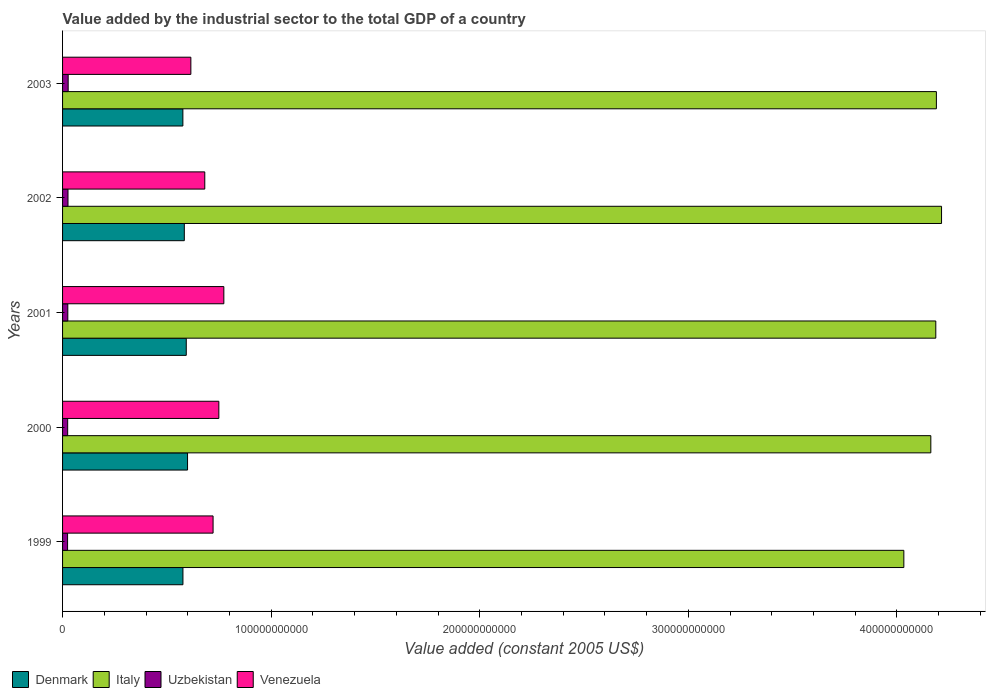How many groups of bars are there?
Your answer should be very brief. 5. In how many cases, is the number of bars for a given year not equal to the number of legend labels?
Provide a succinct answer. 0. What is the value added by the industrial sector in Denmark in 2003?
Keep it short and to the point. 5.77e+1. Across all years, what is the maximum value added by the industrial sector in Venezuela?
Ensure brevity in your answer.  7.73e+1. Across all years, what is the minimum value added by the industrial sector in Italy?
Offer a terse response. 4.03e+11. In which year was the value added by the industrial sector in Denmark maximum?
Ensure brevity in your answer.  2000. What is the total value added by the industrial sector in Venezuela in the graph?
Ensure brevity in your answer.  3.54e+11. What is the difference between the value added by the industrial sector in Italy in 2000 and that in 2003?
Make the answer very short. -2.67e+09. What is the difference between the value added by the industrial sector in Denmark in 1999 and the value added by the industrial sector in Venezuela in 2003?
Provide a short and direct response. -3.80e+09. What is the average value added by the industrial sector in Venezuela per year?
Provide a succinct answer. 7.08e+1. In the year 2003, what is the difference between the value added by the industrial sector in Venezuela and value added by the industrial sector in Italy?
Make the answer very short. -3.57e+11. What is the ratio of the value added by the industrial sector in Denmark in 1999 to that in 2003?
Ensure brevity in your answer.  1. Is the value added by the industrial sector in Italy in 1999 less than that in 2001?
Your response must be concise. Yes. Is the difference between the value added by the industrial sector in Venezuela in 2002 and 2003 greater than the difference between the value added by the industrial sector in Italy in 2002 and 2003?
Offer a very short reply. Yes. What is the difference between the highest and the second highest value added by the industrial sector in Venezuela?
Offer a terse response. 2.40e+09. What is the difference between the highest and the lowest value added by the industrial sector in Venezuela?
Provide a succinct answer. 1.58e+1. Is the sum of the value added by the industrial sector in Uzbekistan in 1999 and 2002 greater than the maximum value added by the industrial sector in Venezuela across all years?
Give a very brief answer. No. Is it the case that in every year, the sum of the value added by the industrial sector in Italy and value added by the industrial sector in Uzbekistan is greater than the value added by the industrial sector in Venezuela?
Provide a succinct answer. Yes. What is the difference between two consecutive major ticks on the X-axis?
Your answer should be compact. 1.00e+11. Does the graph contain grids?
Offer a terse response. No. Where does the legend appear in the graph?
Keep it short and to the point. Bottom left. What is the title of the graph?
Offer a terse response. Value added by the industrial sector to the total GDP of a country. What is the label or title of the X-axis?
Offer a terse response. Value added (constant 2005 US$). What is the label or title of the Y-axis?
Offer a very short reply. Years. What is the Value added (constant 2005 US$) in Denmark in 1999?
Keep it short and to the point. 5.77e+1. What is the Value added (constant 2005 US$) in Italy in 1999?
Offer a terse response. 4.03e+11. What is the Value added (constant 2005 US$) of Uzbekistan in 1999?
Offer a terse response. 2.40e+09. What is the Value added (constant 2005 US$) in Venezuela in 1999?
Offer a terse response. 7.22e+1. What is the Value added (constant 2005 US$) of Denmark in 2000?
Offer a very short reply. 5.99e+1. What is the Value added (constant 2005 US$) in Italy in 2000?
Give a very brief answer. 4.16e+11. What is the Value added (constant 2005 US$) of Uzbekistan in 2000?
Your answer should be compact. 2.45e+09. What is the Value added (constant 2005 US$) of Venezuela in 2000?
Provide a succinct answer. 7.49e+1. What is the Value added (constant 2005 US$) of Denmark in 2001?
Make the answer very short. 5.93e+1. What is the Value added (constant 2005 US$) of Italy in 2001?
Ensure brevity in your answer.  4.19e+11. What is the Value added (constant 2005 US$) in Uzbekistan in 2001?
Your answer should be very brief. 2.52e+09. What is the Value added (constant 2005 US$) of Venezuela in 2001?
Offer a terse response. 7.73e+1. What is the Value added (constant 2005 US$) in Denmark in 2002?
Offer a very short reply. 5.84e+1. What is the Value added (constant 2005 US$) of Italy in 2002?
Offer a very short reply. 4.21e+11. What is the Value added (constant 2005 US$) of Uzbekistan in 2002?
Provide a short and direct response. 2.60e+09. What is the Value added (constant 2005 US$) in Venezuela in 2002?
Your answer should be very brief. 6.82e+1. What is the Value added (constant 2005 US$) in Denmark in 2003?
Provide a short and direct response. 5.77e+1. What is the Value added (constant 2005 US$) in Italy in 2003?
Ensure brevity in your answer.  4.19e+11. What is the Value added (constant 2005 US$) of Uzbekistan in 2003?
Offer a very short reply. 2.69e+09. What is the Value added (constant 2005 US$) in Venezuela in 2003?
Your answer should be compact. 6.15e+1. Across all years, what is the maximum Value added (constant 2005 US$) of Denmark?
Provide a short and direct response. 5.99e+1. Across all years, what is the maximum Value added (constant 2005 US$) in Italy?
Your response must be concise. 4.21e+11. Across all years, what is the maximum Value added (constant 2005 US$) of Uzbekistan?
Make the answer very short. 2.69e+09. Across all years, what is the maximum Value added (constant 2005 US$) in Venezuela?
Give a very brief answer. 7.73e+1. Across all years, what is the minimum Value added (constant 2005 US$) of Denmark?
Ensure brevity in your answer.  5.77e+1. Across all years, what is the minimum Value added (constant 2005 US$) in Italy?
Make the answer very short. 4.03e+11. Across all years, what is the minimum Value added (constant 2005 US$) of Uzbekistan?
Ensure brevity in your answer.  2.40e+09. Across all years, what is the minimum Value added (constant 2005 US$) in Venezuela?
Keep it short and to the point. 6.15e+1. What is the total Value added (constant 2005 US$) of Denmark in the graph?
Provide a short and direct response. 2.93e+11. What is the total Value added (constant 2005 US$) in Italy in the graph?
Keep it short and to the point. 2.08e+12. What is the total Value added (constant 2005 US$) of Uzbekistan in the graph?
Ensure brevity in your answer.  1.27e+1. What is the total Value added (constant 2005 US$) in Venezuela in the graph?
Offer a very short reply. 3.54e+11. What is the difference between the Value added (constant 2005 US$) in Denmark in 1999 and that in 2000?
Offer a terse response. -2.21e+09. What is the difference between the Value added (constant 2005 US$) of Italy in 1999 and that in 2000?
Provide a succinct answer. -1.29e+1. What is the difference between the Value added (constant 2005 US$) in Uzbekistan in 1999 and that in 2000?
Provide a short and direct response. -4.36e+07. What is the difference between the Value added (constant 2005 US$) of Venezuela in 1999 and that in 2000?
Provide a succinct answer. -2.77e+09. What is the difference between the Value added (constant 2005 US$) of Denmark in 1999 and that in 2001?
Give a very brief answer. -1.60e+09. What is the difference between the Value added (constant 2005 US$) of Italy in 1999 and that in 2001?
Keep it short and to the point. -1.53e+1. What is the difference between the Value added (constant 2005 US$) of Uzbekistan in 1999 and that in 2001?
Provide a short and direct response. -1.15e+08. What is the difference between the Value added (constant 2005 US$) of Venezuela in 1999 and that in 2001?
Give a very brief answer. -5.16e+09. What is the difference between the Value added (constant 2005 US$) of Denmark in 1999 and that in 2002?
Ensure brevity in your answer.  -6.62e+08. What is the difference between the Value added (constant 2005 US$) in Italy in 1999 and that in 2002?
Offer a terse response. -1.81e+1. What is the difference between the Value added (constant 2005 US$) of Uzbekistan in 1999 and that in 2002?
Provide a short and direct response. -2.00e+08. What is the difference between the Value added (constant 2005 US$) of Venezuela in 1999 and that in 2002?
Make the answer very short. 3.98e+09. What is the difference between the Value added (constant 2005 US$) in Denmark in 1999 and that in 2003?
Keep it short and to the point. 2.82e+07. What is the difference between the Value added (constant 2005 US$) in Italy in 1999 and that in 2003?
Offer a very short reply. -1.56e+1. What is the difference between the Value added (constant 2005 US$) in Uzbekistan in 1999 and that in 2003?
Make the answer very short. -2.83e+08. What is the difference between the Value added (constant 2005 US$) of Venezuela in 1999 and that in 2003?
Keep it short and to the point. 1.07e+1. What is the difference between the Value added (constant 2005 US$) of Denmark in 2000 and that in 2001?
Keep it short and to the point. 6.13e+08. What is the difference between the Value added (constant 2005 US$) in Italy in 2000 and that in 2001?
Offer a terse response. -2.38e+09. What is the difference between the Value added (constant 2005 US$) in Uzbekistan in 2000 and that in 2001?
Provide a short and direct response. -7.12e+07. What is the difference between the Value added (constant 2005 US$) in Venezuela in 2000 and that in 2001?
Provide a short and direct response. -2.40e+09. What is the difference between the Value added (constant 2005 US$) of Denmark in 2000 and that in 2002?
Give a very brief answer. 1.55e+09. What is the difference between the Value added (constant 2005 US$) in Italy in 2000 and that in 2002?
Offer a terse response. -5.13e+09. What is the difference between the Value added (constant 2005 US$) in Uzbekistan in 2000 and that in 2002?
Ensure brevity in your answer.  -1.57e+08. What is the difference between the Value added (constant 2005 US$) of Venezuela in 2000 and that in 2002?
Give a very brief answer. 6.74e+09. What is the difference between the Value added (constant 2005 US$) of Denmark in 2000 and that in 2003?
Provide a short and direct response. 2.24e+09. What is the difference between the Value added (constant 2005 US$) in Italy in 2000 and that in 2003?
Provide a short and direct response. -2.67e+09. What is the difference between the Value added (constant 2005 US$) of Uzbekistan in 2000 and that in 2003?
Provide a short and direct response. -2.40e+08. What is the difference between the Value added (constant 2005 US$) in Venezuela in 2000 and that in 2003?
Offer a very short reply. 1.34e+1. What is the difference between the Value added (constant 2005 US$) in Denmark in 2001 and that in 2002?
Keep it short and to the point. 9.36e+08. What is the difference between the Value added (constant 2005 US$) in Italy in 2001 and that in 2002?
Your response must be concise. -2.75e+09. What is the difference between the Value added (constant 2005 US$) of Uzbekistan in 2001 and that in 2002?
Provide a succinct answer. -8.56e+07. What is the difference between the Value added (constant 2005 US$) of Venezuela in 2001 and that in 2002?
Your response must be concise. 9.14e+09. What is the difference between the Value added (constant 2005 US$) of Denmark in 2001 and that in 2003?
Give a very brief answer. 1.63e+09. What is the difference between the Value added (constant 2005 US$) of Italy in 2001 and that in 2003?
Ensure brevity in your answer.  -2.83e+08. What is the difference between the Value added (constant 2005 US$) in Uzbekistan in 2001 and that in 2003?
Offer a terse response. -1.68e+08. What is the difference between the Value added (constant 2005 US$) of Venezuela in 2001 and that in 2003?
Offer a terse response. 1.58e+1. What is the difference between the Value added (constant 2005 US$) of Denmark in 2002 and that in 2003?
Keep it short and to the point. 6.90e+08. What is the difference between the Value added (constant 2005 US$) of Italy in 2002 and that in 2003?
Your answer should be very brief. 2.47e+09. What is the difference between the Value added (constant 2005 US$) in Uzbekistan in 2002 and that in 2003?
Provide a short and direct response. -8.27e+07. What is the difference between the Value added (constant 2005 US$) of Venezuela in 2002 and that in 2003?
Your answer should be very brief. 6.68e+09. What is the difference between the Value added (constant 2005 US$) of Denmark in 1999 and the Value added (constant 2005 US$) of Italy in 2000?
Provide a short and direct response. -3.59e+11. What is the difference between the Value added (constant 2005 US$) in Denmark in 1999 and the Value added (constant 2005 US$) in Uzbekistan in 2000?
Provide a succinct answer. 5.53e+1. What is the difference between the Value added (constant 2005 US$) in Denmark in 1999 and the Value added (constant 2005 US$) in Venezuela in 2000?
Keep it short and to the point. -1.72e+1. What is the difference between the Value added (constant 2005 US$) in Italy in 1999 and the Value added (constant 2005 US$) in Uzbekistan in 2000?
Ensure brevity in your answer.  4.01e+11. What is the difference between the Value added (constant 2005 US$) of Italy in 1999 and the Value added (constant 2005 US$) of Venezuela in 2000?
Offer a terse response. 3.28e+11. What is the difference between the Value added (constant 2005 US$) in Uzbekistan in 1999 and the Value added (constant 2005 US$) in Venezuela in 2000?
Keep it short and to the point. -7.25e+1. What is the difference between the Value added (constant 2005 US$) of Denmark in 1999 and the Value added (constant 2005 US$) of Italy in 2001?
Your response must be concise. -3.61e+11. What is the difference between the Value added (constant 2005 US$) of Denmark in 1999 and the Value added (constant 2005 US$) of Uzbekistan in 2001?
Make the answer very short. 5.52e+1. What is the difference between the Value added (constant 2005 US$) in Denmark in 1999 and the Value added (constant 2005 US$) in Venezuela in 2001?
Keep it short and to the point. -1.96e+1. What is the difference between the Value added (constant 2005 US$) of Italy in 1999 and the Value added (constant 2005 US$) of Uzbekistan in 2001?
Offer a very short reply. 4.01e+11. What is the difference between the Value added (constant 2005 US$) of Italy in 1999 and the Value added (constant 2005 US$) of Venezuela in 2001?
Your answer should be very brief. 3.26e+11. What is the difference between the Value added (constant 2005 US$) of Uzbekistan in 1999 and the Value added (constant 2005 US$) of Venezuela in 2001?
Keep it short and to the point. -7.49e+1. What is the difference between the Value added (constant 2005 US$) of Denmark in 1999 and the Value added (constant 2005 US$) of Italy in 2002?
Your answer should be very brief. -3.64e+11. What is the difference between the Value added (constant 2005 US$) in Denmark in 1999 and the Value added (constant 2005 US$) in Uzbekistan in 2002?
Your answer should be compact. 5.51e+1. What is the difference between the Value added (constant 2005 US$) in Denmark in 1999 and the Value added (constant 2005 US$) in Venezuela in 2002?
Offer a very short reply. -1.05e+1. What is the difference between the Value added (constant 2005 US$) in Italy in 1999 and the Value added (constant 2005 US$) in Uzbekistan in 2002?
Make the answer very short. 4.01e+11. What is the difference between the Value added (constant 2005 US$) in Italy in 1999 and the Value added (constant 2005 US$) in Venezuela in 2002?
Keep it short and to the point. 3.35e+11. What is the difference between the Value added (constant 2005 US$) of Uzbekistan in 1999 and the Value added (constant 2005 US$) of Venezuela in 2002?
Your answer should be compact. -6.58e+1. What is the difference between the Value added (constant 2005 US$) in Denmark in 1999 and the Value added (constant 2005 US$) in Italy in 2003?
Offer a terse response. -3.61e+11. What is the difference between the Value added (constant 2005 US$) in Denmark in 1999 and the Value added (constant 2005 US$) in Uzbekistan in 2003?
Your response must be concise. 5.50e+1. What is the difference between the Value added (constant 2005 US$) in Denmark in 1999 and the Value added (constant 2005 US$) in Venezuela in 2003?
Your response must be concise. -3.80e+09. What is the difference between the Value added (constant 2005 US$) in Italy in 1999 and the Value added (constant 2005 US$) in Uzbekistan in 2003?
Provide a succinct answer. 4.01e+11. What is the difference between the Value added (constant 2005 US$) of Italy in 1999 and the Value added (constant 2005 US$) of Venezuela in 2003?
Give a very brief answer. 3.42e+11. What is the difference between the Value added (constant 2005 US$) in Uzbekistan in 1999 and the Value added (constant 2005 US$) in Venezuela in 2003?
Your answer should be very brief. -5.91e+1. What is the difference between the Value added (constant 2005 US$) of Denmark in 2000 and the Value added (constant 2005 US$) of Italy in 2001?
Offer a very short reply. -3.59e+11. What is the difference between the Value added (constant 2005 US$) in Denmark in 2000 and the Value added (constant 2005 US$) in Uzbekistan in 2001?
Your answer should be very brief. 5.74e+1. What is the difference between the Value added (constant 2005 US$) of Denmark in 2000 and the Value added (constant 2005 US$) of Venezuela in 2001?
Offer a terse response. -1.74e+1. What is the difference between the Value added (constant 2005 US$) in Italy in 2000 and the Value added (constant 2005 US$) in Uzbekistan in 2001?
Your response must be concise. 4.14e+11. What is the difference between the Value added (constant 2005 US$) in Italy in 2000 and the Value added (constant 2005 US$) in Venezuela in 2001?
Provide a succinct answer. 3.39e+11. What is the difference between the Value added (constant 2005 US$) in Uzbekistan in 2000 and the Value added (constant 2005 US$) in Venezuela in 2001?
Make the answer very short. -7.49e+1. What is the difference between the Value added (constant 2005 US$) of Denmark in 2000 and the Value added (constant 2005 US$) of Italy in 2002?
Give a very brief answer. -3.61e+11. What is the difference between the Value added (constant 2005 US$) of Denmark in 2000 and the Value added (constant 2005 US$) of Uzbekistan in 2002?
Give a very brief answer. 5.73e+1. What is the difference between the Value added (constant 2005 US$) in Denmark in 2000 and the Value added (constant 2005 US$) in Venezuela in 2002?
Your answer should be compact. -8.26e+09. What is the difference between the Value added (constant 2005 US$) of Italy in 2000 and the Value added (constant 2005 US$) of Uzbekistan in 2002?
Keep it short and to the point. 4.14e+11. What is the difference between the Value added (constant 2005 US$) in Italy in 2000 and the Value added (constant 2005 US$) in Venezuela in 2002?
Give a very brief answer. 3.48e+11. What is the difference between the Value added (constant 2005 US$) of Uzbekistan in 2000 and the Value added (constant 2005 US$) of Venezuela in 2002?
Provide a succinct answer. -6.57e+1. What is the difference between the Value added (constant 2005 US$) in Denmark in 2000 and the Value added (constant 2005 US$) in Italy in 2003?
Keep it short and to the point. -3.59e+11. What is the difference between the Value added (constant 2005 US$) in Denmark in 2000 and the Value added (constant 2005 US$) in Uzbekistan in 2003?
Keep it short and to the point. 5.72e+1. What is the difference between the Value added (constant 2005 US$) of Denmark in 2000 and the Value added (constant 2005 US$) of Venezuela in 2003?
Offer a terse response. -1.59e+09. What is the difference between the Value added (constant 2005 US$) of Italy in 2000 and the Value added (constant 2005 US$) of Uzbekistan in 2003?
Provide a succinct answer. 4.14e+11. What is the difference between the Value added (constant 2005 US$) in Italy in 2000 and the Value added (constant 2005 US$) in Venezuela in 2003?
Give a very brief answer. 3.55e+11. What is the difference between the Value added (constant 2005 US$) of Uzbekistan in 2000 and the Value added (constant 2005 US$) of Venezuela in 2003?
Give a very brief answer. -5.91e+1. What is the difference between the Value added (constant 2005 US$) in Denmark in 2001 and the Value added (constant 2005 US$) in Italy in 2002?
Your answer should be compact. -3.62e+11. What is the difference between the Value added (constant 2005 US$) of Denmark in 2001 and the Value added (constant 2005 US$) of Uzbekistan in 2002?
Keep it short and to the point. 5.67e+1. What is the difference between the Value added (constant 2005 US$) of Denmark in 2001 and the Value added (constant 2005 US$) of Venezuela in 2002?
Ensure brevity in your answer.  -8.88e+09. What is the difference between the Value added (constant 2005 US$) in Italy in 2001 and the Value added (constant 2005 US$) in Uzbekistan in 2002?
Give a very brief answer. 4.16e+11. What is the difference between the Value added (constant 2005 US$) in Italy in 2001 and the Value added (constant 2005 US$) in Venezuela in 2002?
Give a very brief answer. 3.50e+11. What is the difference between the Value added (constant 2005 US$) of Uzbekistan in 2001 and the Value added (constant 2005 US$) of Venezuela in 2002?
Offer a terse response. -6.57e+1. What is the difference between the Value added (constant 2005 US$) of Denmark in 2001 and the Value added (constant 2005 US$) of Italy in 2003?
Your answer should be compact. -3.60e+11. What is the difference between the Value added (constant 2005 US$) in Denmark in 2001 and the Value added (constant 2005 US$) in Uzbekistan in 2003?
Keep it short and to the point. 5.66e+1. What is the difference between the Value added (constant 2005 US$) in Denmark in 2001 and the Value added (constant 2005 US$) in Venezuela in 2003?
Your response must be concise. -2.20e+09. What is the difference between the Value added (constant 2005 US$) of Italy in 2001 and the Value added (constant 2005 US$) of Uzbekistan in 2003?
Ensure brevity in your answer.  4.16e+11. What is the difference between the Value added (constant 2005 US$) in Italy in 2001 and the Value added (constant 2005 US$) in Venezuela in 2003?
Provide a short and direct response. 3.57e+11. What is the difference between the Value added (constant 2005 US$) in Uzbekistan in 2001 and the Value added (constant 2005 US$) in Venezuela in 2003?
Your answer should be very brief. -5.90e+1. What is the difference between the Value added (constant 2005 US$) of Denmark in 2002 and the Value added (constant 2005 US$) of Italy in 2003?
Offer a very short reply. -3.61e+11. What is the difference between the Value added (constant 2005 US$) in Denmark in 2002 and the Value added (constant 2005 US$) in Uzbekistan in 2003?
Ensure brevity in your answer.  5.57e+1. What is the difference between the Value added (constant 2005 US$) of Denmark in 2002 and the Value added (constant 2005 US$) of Venezuela in 2003?
Keep it short and to the point. -3.14e+09. What is the difference between the Value added (constant 2005 US$) of Italy in 2002 and the Value added (constant 2005 US$) of Uzbekistan in 2003?
Ensure brevity in your answer.  4.19e+11. What is the difference between the Value added (constant 2005 US$) of Italy in 2002 and the Value added (constant 2005 US$) of Venezuela in 2003?
Your response must be concise. 3.60e+11. What is the difference between the Value added (constant 2005 US$) of Uzbekistan in 2002 and the Value added (constant 2005 US$) of Venezuela in 2003?
Your answer should be very brief. -5.89e+1. What is the average Value added (constant 2005 US$) in Denmark per year?
Offer a very short reply. 5.86e+1. What is the average Value added (constant 2005 US$) in Italy per year?
Your response must be concise. 4.16e+11. What is the average Value added (constant 2005 US$) of Uzbekistan per year?
Offer a very short reply. 2.53e+09. What is the average Value added (constant 2005 US$) of Venezuela per year?
Keep it short and to the point. 7.08e+1. In the year 1999, what is the difference between the Value added (constant 2005 US$) of Denmark and Value added (constant 2005 US$) of Italy?
Your answer should be very brief. -3.46e+11. In the year 1999, what is the difference between the Value added (constant 2005 US$) in Denmark and Value added (constant 2005 US$) in Uzbekistan?
Ensure brevity in your answer.  5.53e+1. In the year 1999, what is the difference between the Value added (constant 2005 US$) of Denmark and Value added (constant 2005 US$) of Venezuela?
Your response must be concise. -1.45e+1. In the year 1999, what is the difference between the Value added (constant 2005 US$) in Italy and Value added (constant 2005 US$) in Uzbekistan?
Your answer should be compact. 4.01e+11. In the year 1999, what is the difference between the Value added (constant 2005 US$) of Italy and Value added (constant 2005 US$) of Venezuela?
Your answer should be compact. 3.31e+11. In the year 1999, what is the difference between the Value added (constant 2005 US$) in Uzbekistan and Value added (constant 2005 US$) in Venezuela?
Provide a short and direct response. -6.98e+1. In the year 2000, what is the difference between the Value added (constant 2005 US$) in Denmark and Value added (constant 2005 US$) in Italy?
Keep it short and to the point. -3.56e+11. In the year 2000, what is the difference between the Value added (constant 2005 US$) of Denmark and Value added (constant 2005 US$) of Uzbekistan?
Offer a very short reply. 5.75e+1. In the year 2000, what is the difference between the Value added (constant 2005 US$) in Denmark and Value added (constant 2005 US$) in Venezuela?
Ensure brevity in your answer.  -1.50e+1. In the year 2000, what is the difference between the Value added (constant 2005 US$) of Italy and Value added (constant 2005 US$) of Uzbekistan?
Provide a short and direct response. 4.14e+11. In the year 2000, what is the difference between the Value added (constant 2005 US$) of Italy and Value added (constant 2005 US$) of Venezuela?
Give a very brief answer. 3.41e+11. In the year 2000, what is the difference between the Value added (constant 2005 US$) of Uzbekistan and Value added (constant 2005 US$) of Venezuela?
Give a very brief answer. -7.25e+1. In the year 2001, what is the difference between the Value added (constant 2005 US$) in Denmark and Value added (constant 2005 US$) in Italy?
Provide a succinct answer. -3.59e+11. In the year 2001, what is the difference between the Value added (constant 2005 US$) of Denmark and Value added (constant 2005 US$) of Uzbekistan?
Keep it short and to the point. 5.68e+1. In the year 2001, what is the difference between the Value added (constant 2005 US$) in Denmark and Value added (constant 2005 US$) in Venezuela?
Your answer should be compact. -1.80e+1. In the year 2001, what is the difference between the Value added (constant 2005 US$) in Italy and Value added (constant 2005 US$) in Uzbekistan?
Your response must be concise. 4.16e+11. In the year 2001, what is the difference between the Value added (constant 2005 US$) in Italy and Value added (constant 2005 US$) in Venezuela?
Keep it short and to the point. 3.41e+11. In the year 2001, what is the difference between the Value added (constant 2005 US$) in Uzbekistan and Value added (constant 2005 US$) in Venezuela?
Give a very brief answer. -7.48e+1. In the year 2002, what is the difference between the Value added (constant 2005 US$) of Denmark and Value added (constant 2005 US$) of Italy?
Provide a short and direct response. -3.63e+11. In the year 2002, what is the difference between the Value added (constant 2005 US$) of Denmark and Value added (constant 2005 US$) of Uzbekistan?
Keep it short and to the point. 5.58e+1. In the year 2002, what is the difference between the Value added (constant 2005 US$) in Denmark and Value added (constant 2005 US$) in Venezuela?
Give a very brief answer. -9.81e+09. In the year 2002, what is the difference between the Value added (constant 2005 US$) of Italy and Value added (constant 2005 US$) of Uzbekistan?
Provide a succinct answer. 4.19e+11. In the year 2002, what is the difference between the Value added (constant 2005 US$) of Italy and Value added (constant 2005 US$) of Venezuela?
Provide a succinct answer. 3.53e+11. In the year 2002, what is the difference between the Value added (constant 2005 US$) in Uzbekistan and Value added (constant 2005 US$) in Venezuela?
Your answer should be compact. -6.56e+1. In the year 2003, what is the difference between the Value added (constant 2005 US$) in Denmark and Value added (constant 2005 US$) in Italy?
Your answer should be compact. -3.61e+11. In the year 2003, what is the difference between the Value added (constant 2005 US$) of Denmark and Value added (constant 2005 US$) of Uzbekistan?
Your answer should be very brief. 5.50e+1. In the year 2003, what is the difference between the Value added (constant 2005 US$) in Denmark and Value added (constant 2005 US$) in Venezuela?
Ensure brevity in your answer.  -3.83e+09. In the year 2003, what is the difference between the Value added (constant 2005 US$) in Italy and Value added (constant 2005 US$) in Uzbekistan?
Provide a short and direct response. 4.16e+11. In the year 2003, what is the difference between the Value added (constant 2005 US$) in Italy and Value added (constant 2005 US$) in Venezuela?
Ensure brevity in your answer.  3.57e+11. In the year 2003, what is the difference between the Value added (constant 2005 US$) in Uzbekistan and Value added (constant 2005 US$) in Venezuela?
Keep it short and to the point. -5.88e+1. What is the ratio of the Value added (constant 2005 US$) in Denmark in 1999 to that in 2000?
Ensure brevity in your answer.  0.96. What is the ratio of the Value added (constant 2005 US$) in Italy in 1999 to that in 2000?
Offer a very short reply. 0.97. What is the ratio of the Value added (constant 2005 US$) of Uzbekistan in 1999 to that in 2000?
Give a very brief answer. 0.98. What is the ratio of the Value added (constant 2005 US$) in Venezuela in 1999 to that in 2000?
Your answer should be very brief. 0.96. What is the ratio of the Value added (constant 2005 US$) of Denmark in 1999 to that in 2001?
Offer a terse response. 0.97. What is the ratio of the Value added (constant 2005 US$) in Italy in 1999 to that in 2001?
Ensure brevity in your answer.  0.96. What is the ratio of the Value added (constant 2005 US$) in Uzbekistan in 1999 to that in 2001?
Ensure brevity in your answer.  0.95. What is the ratio of the Value added (constant 2005 US$) of Venezuela in 1999 to that in 2001?
Give a very brief answer. 0.93. What is the ratio of the Value added (constant 2005 US$) of Denmark in 1999 to that in 2002?
Provide a short and direct response. 0.99. What is the ratio of the Value added (constant 2005 US$) of Italy in 1999 to that in 2002?
Give a very brief answer. 0.96. What is the ratio of the Value added (constant 2005 US$) of Uzbekistan in 1999 to that in 2002?
Offer a terse response. 0.92. What is the ratio of the Value added (constant 2005 US$) in Venezuela in 1999 to that in 2002?
Offer a very short reply. 1.06. What is the ratio of the Value added (constant 2005 US$) in Denmark in 1999 to that in 2003?
Make the answer very short. 1. What is the ratio of the Value added (constant 2005 US$) in Italy in 1999 to that in 2003?
Give a very brief answer. 0.96. What is the ratio of the Value added (constant 2005 US$) of Uzbekistan in 1999 to that in 2003?
Make the answer very short. 0.89. What is the ratio of the Value added (constant 2005 US$) of Venezuela in 1999 to that in 2003?
Ensure brevity in your answer.  1.17. What is the ratio of the Value added (constant 2005 US$) in Denmark in 2000 to that in 2001?
Give a very brief answer. 1.01. What is the ratio of the Value added (constant 2005 US$) in Italy in 2000 to that in 2001?
Provide a short and direct response. 0.99. What is the ratio of the Value added (constant 2005 US$) of Uzbekistan in 2000 to that in 2001?
Offer a very short reply. 0.97. What is the ratio of the Value added (constant 2005 US$) in Denmark in 2000 to that in 2002?
Keep it short and to the point. 1.03. What is the ratio of the Value added (constant 2005 US$) in Uzbekistan in 2000 to that in 2002?
Your response must be concise. 0.94. What is the ratio of the Value added (constant 2005 US$) in Venezuela in 2000 to that in 2002?
Your answer should be compact. 1.1. What is the ratio of the Value added (constant 2005 US$) of Denmark in 2000 to that in 2003?
Give a very brief answer. 1.04. What is the ratio of the Value added (constant 2005 US$) of Uzbekistan in 2000 to that in 2003?
Offer a terse response. 0.91. What is the ratio of the Value added (constant 2005 US$) in Venezuela in 2000 to that in 2003?
Provide a short and direct response. 1.22. What is the ratio of the Value added (constant 2005 US$) in Uzbekistan in 2001 to that in 2002?
Make the answer very short. 0.97. What is the ratio of the Value added (constant 2005 US$) in Venezuela in 2001 to that in 2002?
Give a very brief answer. 1.13. What is the ratio of the Value added (constant 2005 US$) of Denmark in 2001 to that in 2003?
Your answer should be compact. 1.03. What is the ratio of the Value added (constant 2005 US$) of Italy in 2001 to that in 2003?
Offer a very short reply. 1. What is the ratio of the Value added (constant 2005 US$) of Uzbekistan in 2001 to that in 2003?
Ensure brevity in your answer.  0.94. What is the ratio of the Value added (constant 2005 US$) in Venezuela in 2001 to that in 2003?
Provide a succinct answer. 1.26. What is the ratio of the Value added (constant 2005 US$) of Italy in 2002 to that in 2003?
Keep it short and to the point. 1.01. What is the ratio of the Value added (constant 2005 US$) in Uzbekistan in 2002 to that in 2003?
Offer a terse response. 0.97. What is the ratio of the Value added (constant 2005 US$) of Venezuela in 2002 to that in 2003?
Provide a succinct answer. 1.11. What is the difference between the highest and the second highest Value added (constant 2005 US$) of Denmark?
Offer a terse response. 6.13e+08. What is the difference between the highest and the second highest Value added (constant 2005 US$) of Italy?
Keep it short and to the point. 2.47e+09. What is the difference between the highest and the second highest Value added (constant 2005 US$) in Uzbekistan?
Make the answer very short. 8.27e+07. What is the difference between the highest and the second highest Value added (constant 2005 US$) in Venezuela?
Make the answer very short. 2.40e+09. What is the difference between the highest and the lowest Value added (constant 2005 US$) of Denmark?
Keep it short and to the point. 2.24e+09. What is the difference between the highest and the lowest Value added (constant 2005 US$) of Italy?
Offer a very short reply. 1.81e+1. What is the difference between the highest and the lowest Value added (constant 2005 US$) of Uzbekistan?
Offer a very short reply. 2.83e+08. What is the difference between the highest and the lowest Value added (constant 2005 US$) of Venezuela?
Keep it short and to the point. 1.58e+1. 